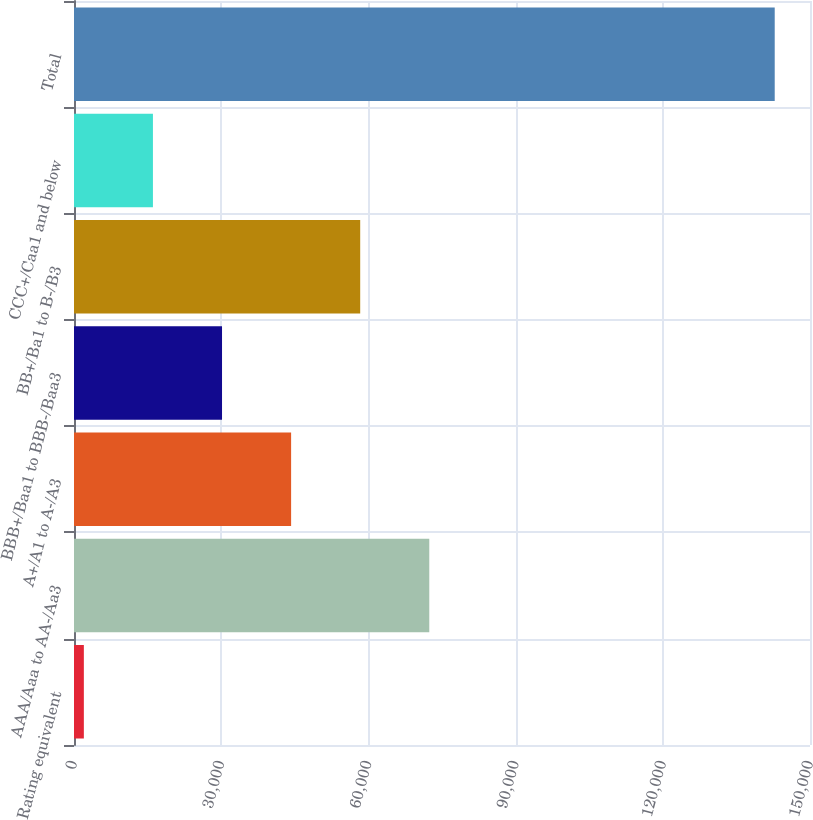Convert chart. <chart><loc_0><loc_0><loc_500><loc_500><bar_chart><fcel>Rating equivalent<fcel>AAA/Aaa to AA-/Aa3<fcel>A+/A1 to A-/A3<fcel>BBB+/Baa1 to BBB-/Baa3<fcel>BB+/Ba1 to B-/B3<fcel>CCC+/Caa1 and below<fcel>Total<nl><fcel>2008<fcel>72409<fcel>44248.6<fcel>30168.4<fcel>58328.8<fcel>16088.2<fcel>142810<nl></chart> 